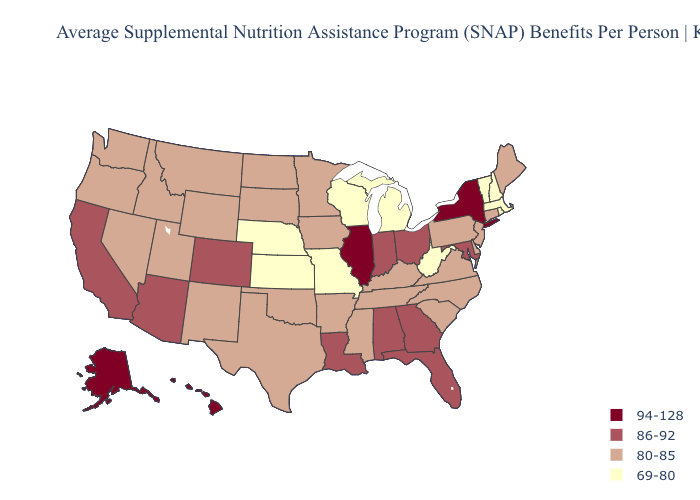What is the highest value in the Northeast ?
Be succinct. 94-128. Does the first symbol in the legend represent the smallest category?
Concise answer only. No. Does South Dakota have the same value as Kansas?
Write a very short answer. No. What is the value of Virginia?
Give a very brief answer. 80-85. What is the lowest value in the USA?
Quick response, please. 69-80. What is the value of Alaska?
Quick response, please. 94-128. Which states hav the highest value in the MidWest?
Keep it brief. Illinois. Does Alaska have the highest value in the USA?
Keep it brief. Yes. Does the map have missing data?
Keep it brief. No. Among the states that border Indiana , does Ohio have the highest value?
Give a very brief answer. No. Among the states that border Ohio , does Indiana have the highest value?
Give a very brief answer. Yes. Does South Carolina have a lower value than Illinois?
Be succinct. Yes. Does Washington have the highest value in the USA?
Short answer required. No. Name the states that have a value in the range 94-128?
Give a very brief answer. Alaska, Hawaii, Illinois, New York. 